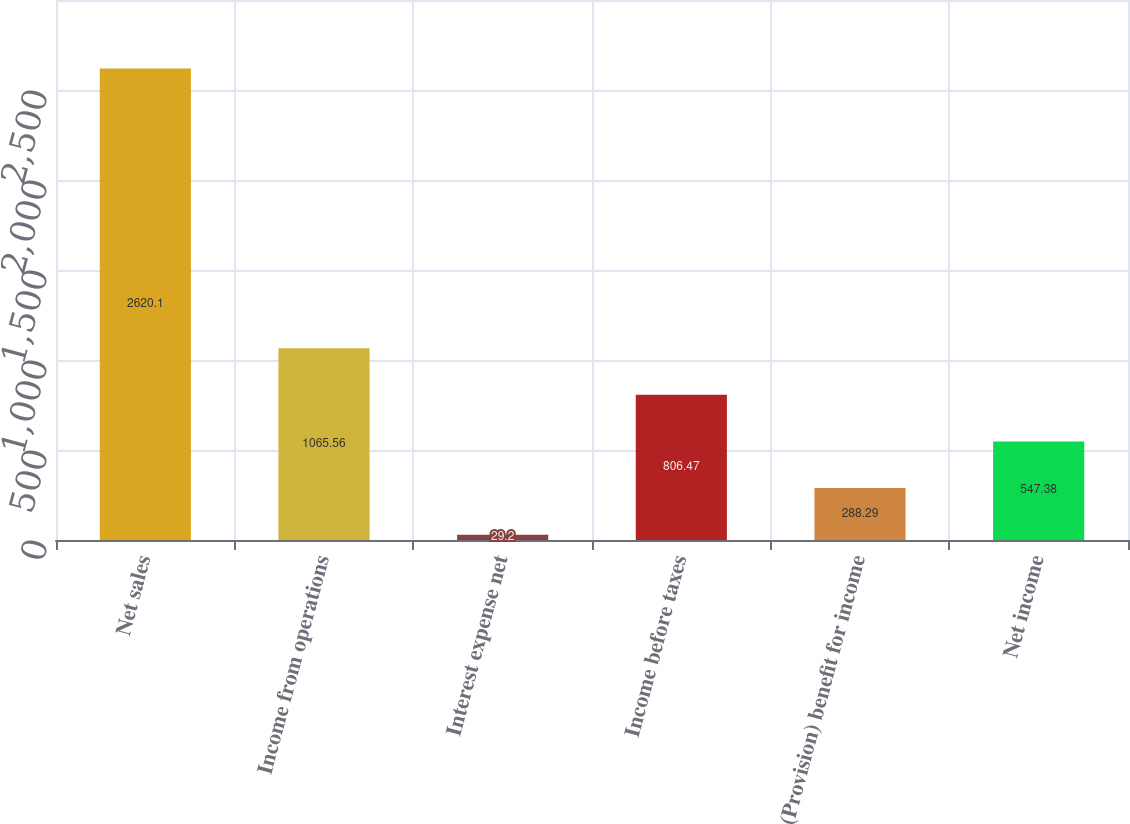<chart> <loc_0><loc_0><loc_500><loc_500><bar_chart><fcel>Net sales<fcel>Income from operations<fcel>Interest expense net<fcel>Income before taxes<fcel>(Provision) benefit for income<fcel>Net income<nl><fcel>2620.1<fcel>1065.56<fcel>29.2<fcel>806.47<fcel>288.29<fcel>547.38<nl></chart> 